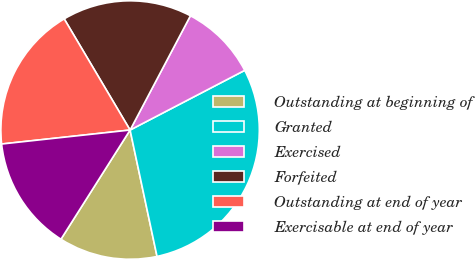Convert chart. <chart><loc_0><loc_0><loc_500><loc_500><pie_chart><fcel>Outstanding at beginning of<fcel>Granted<fcel>Exercised<fcel>Forfeited<fcel>Outstanding at end of year<fcel>Exercisable at end of year<nl><fcel>12.33%<fcel>29.3%<fcel>9.63%<fcel>16.25%<fcel>18.21%<fcel>14.29%<nl></chart> 